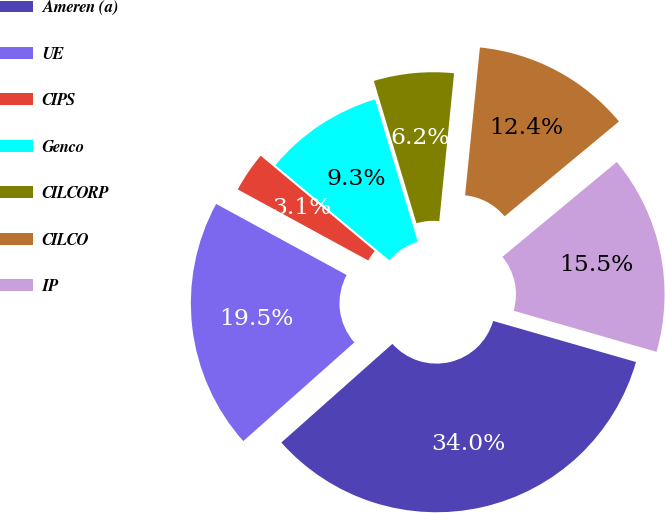Convert chart to OTSL. <chart><loc_0><loc_0><loc_500><loc_500><pie_chart><fcel>Ameren (a)<fcel>UE<fcel>CIPS<fcel>Genco<fcel>CILCORP<fcel>CILCO<fcel>IP<nl><fcel>33.98%<fcel>19.5%<fcel>3.13%<fcel>9.3%<fcel>6.22%<fcel>12.39%<fcel>15.47%<nl></chart> 